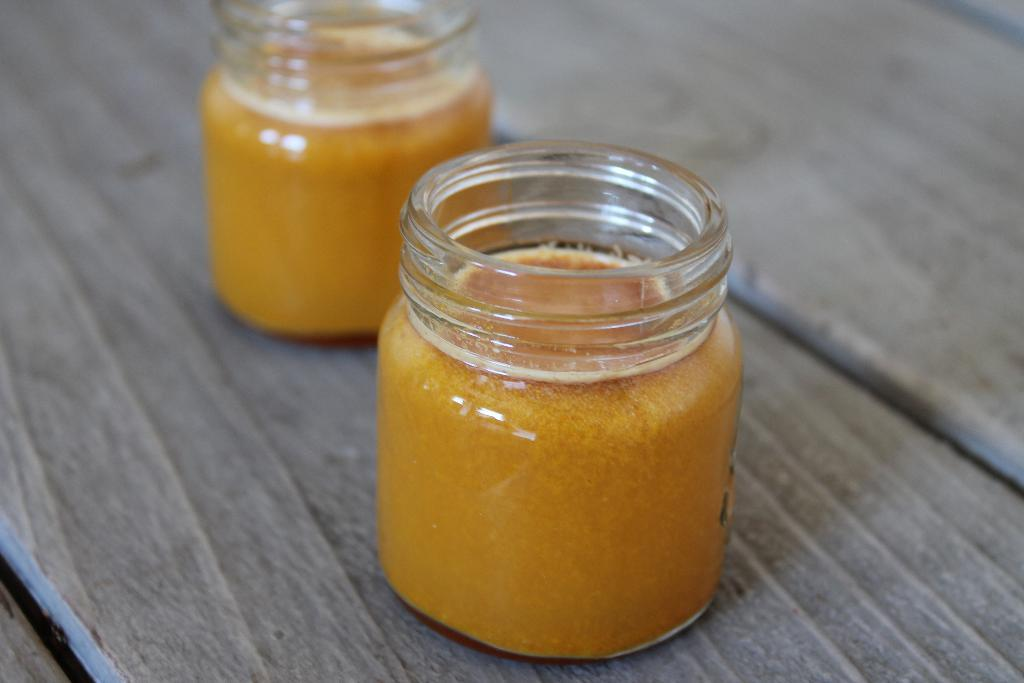What type of containers are visible in the image? There are glass jars in the image. What is inside the glass jars? The glass jars contain food. What material is the surface on which the glass jars are placed? The wooden surface is present in the image. What plot of land can be seen in the image? There is no plot of land visible in the image; it features glass jars containing food on a wooden surface. 